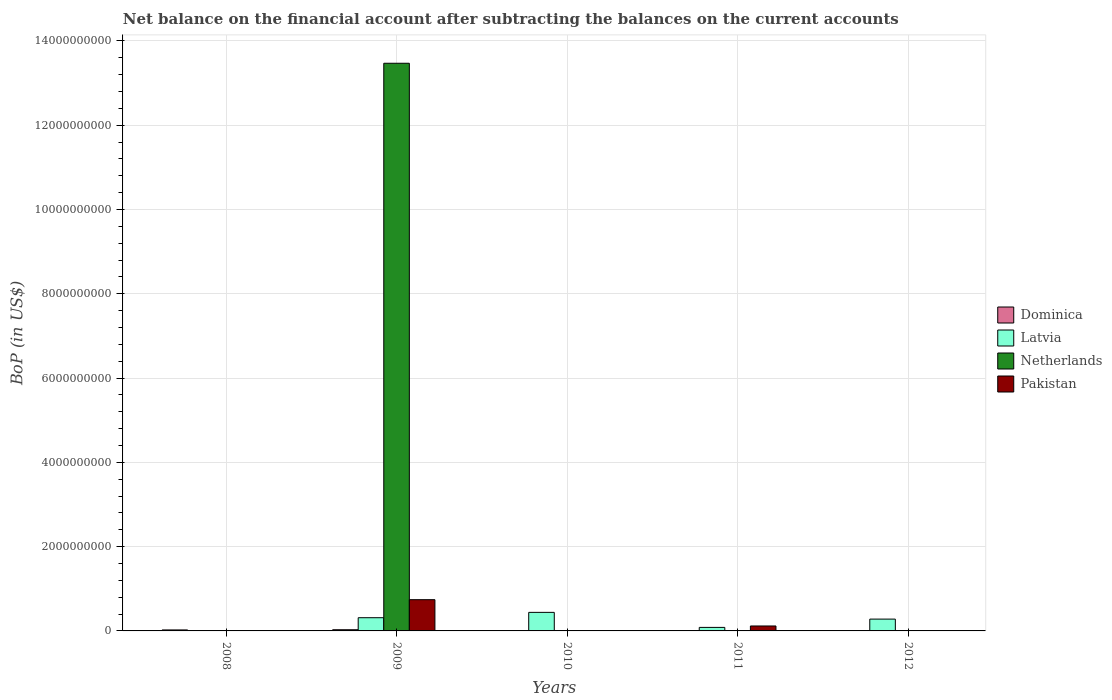Are the number of bars on each tick of the X-axis equal?
Keep it short and to the point. No. How many bars are there on the 4th tick from the left?
Ensure brevity in your answer.  2. What is the Balance of Payments in Latvia in 2010?
Offer a very short reply. 4.40e+08. Across all years, what is the maximum Balance of Payments in Dominica?
Make the answer very short. 2.83e+07. In which year was the Balance of Payments in Pakistan maximum?
Offer a terse response. 2009. What is the total Balance of Payments in Netherlands in the graph?
Your answer should be very brief. 1.35e+1. What is the difference between the Balance of Payments in Latvia in 2010 and that in 2012?
Your answer should be compact. 1.60e+08. What is the difference between the Balance of Payments in Netherlands in 2008 and the Balance of Payments in Latvia in 2009?
Your answer should be very brief. -3.13e+08. What is the average Balance of Payments in Dominica per year?
Offer a terse response. 1.20e+07. In the year 2009, what is the difference between the Balance of Payments in Latvia and Balance of Payments in Pakistan?
Offer a very short reply. -4.28e+08. In how many years, is the Balance of Payments in Netherlands greater than 800000000 US$?
Provide a succinct answer. 1. What is the ratio of the Balance of Payments in Dominica in 2008 to that in 2009?
Your response must be concise. 0.83. What is the difference between the highest and the second highest Balance of Payments in Dominica?
Offer a very short reply. 4.71e+06. What is the difference between the highest and the lowest Balance of Payments in Netherlands?
Ensure brevity in your answer.  1.35e+1. In how many years, is the Balance of Payments in Dominica greater than the average Balance of Payments in Dominica taken over all years?
Your answer should be compact. 2. How many bars are there?
Keep it short and to the point. 10. Are all the bars in the graph horizontal?
Make the answer very short. No. How many legend labels are there?
Make the answer very short. 4. What is the title of the graph?
Make the answer very short. Net balance on the financial account after subtracting the balances on the current accounts. What is the label or title of the Y-axis?
Ensure brevity in your answer.  BoP (in US$). What is the BoP (in US$) in Dominica in 2008?
Offer a terse response. 2.36e+07. What is the BoP (in US$) in Latvia in 2008?
Your answer should be compact. 0. What is the BoP (in US$) of Netherlands in 2008?
Your response must be concise. 0. What is the BoP (in US$) in Pakistan in 2008?
Make the answer very short. 0. What is the BoP (in US$) in Dominica in 2009?
Ensure brevity in your answer.  2.83e+07. What is the BoP (in US$) in Latvia in 2009?
Ensure brevity in your answer.  3.13e+08. What is the BoP (in US$) of Netherlands in 2009?
Your response must be concise. 1.35e+1. What is the BoP (in US$) of Pakistan in 2009?
Provide a succinct answer. 7.41e+08. What is the BoP (in US$) in Dominica in 2010?
Ensure brevity in your answer.  0. What is the BoP (in US$) in Latvia in 2010?
Your answer should be very brief. 4.40e+08. What is the BoP (in US$) in Netherlands in 2010?
Ensure brevity in your answer.  0. What is the BoP (in US$) of Latvia in 2011?
Ensure brevity in your answer.  8.38e+07. What is the BoP (in US$) of Pakistan in 2011?
Make the answer very short. 1.17e+08. What is the BoP (in US$) of Dominica in 2012?
Give a very brief answer. 8.08e+06. What is the BoP (in US$) of Latvia in 2012?
Your answer should be compact. 2.81e+08. What is the BoP (in US$) of Netherlands in 2012?
Offer a terse response. 0. Across all years, what is the maximum BoP (in US$) in Dominica?
Provide a short and direct response. 2.83e+07. Across all years, what is the maximum BoP (in US$) of Latvia?
Offer a very short reply. 4.40e+08. Across all years, what is the maximum BoP (in US$) in Netherlands?
Make the answer very short. 1.35e+1. Across all years, what is the maximum BoP (in US$) in Pakistan?
Make the answer very short. 7.41e+08. Across all years, what is the minimum BoP (in US$) in Dominica?
Make the answer very short. 0. Across all years, what is the minimum BoP (in US$) of Netherlands?
Your answer should be very brief. 0. What is the total BoP (in US$) of Dominica in the graph?
Give a very brief answer. 5.99e+07. What is the total BoP (in US$) of Latvia in the graph?
Offer a terse response. 1.12e+09. What is the total BoP (in US$) of Netherlands in the graph?
Provide a short and direct response. 1.35e+1. What is the total BoP (in US$) in Pakistan in the graph?
Your answer should be compact. 8.59e+08. What is the difference between the BoP (in US$) of Dominica in 2008 and that in 2009?
Ensure brevity in your answer.  -4.71e+06. What is the difference between the BoP (in US$) in Dominica in 2008 and that in 2012?
Offer a very short reply. 1.55e+07. What is the difference between the BoP (in US$) of Latvia in 2009 and that in 2010?
Make the answer very short. -1.27e+08. What is the difference between the BoP (in US$) in Latvia in 2009 and that in 2011?
Provide a short and direct response. 2.30e+08. What is the difference between the BoP (in US$) in Pakistan in 2009 and that in 2011?
Keep it short and to the point. 6.24e+08. What is the difference between the BoP (in US$) of Dominica in 2009 and that in 2012?
Offer a terse response. 2.02e+07. What is the difference between the BoP (in US$) in Latvia in 2009 and that in 2012?
Keep it short and to the point. 3.28e+07. What is the difference between the BoP (in US$) of Latvia in 2010 and that in 2011?
Your response must be concise. 3.57e+08. What is the difference between the BoP (in US$) of Latvia in 2010 and that in 2012?
Give a very brief answer. 1.60e+08. What is the difference between the BoP (in US$) in Latvia in 2011 and that in 2012?
Offer a terse response. -1.97e+08. What is the difference between the BoP (in US$) in Dominica in 2008 and the BoP (in US$) in Latvia in 2009?
Your answer should be very brief. -2.90e+08. What is the difference between the BoP (in US$) in Dominica in 2008 and the BoP (in US$) in Netherlands in 2009?
Offer a terse response. -1.34e+1. What is the difference between the BoP (in US$) of Dominica in 2008 and the BoP (in US$) of Pakistan in 2009?
Your response must be concise. -7.18e+08. What is the difference between the BoP (in US$) of Dominica in 2008 and the BoP (in US$) of Latvia in 2010?
Give a very brief answer. -4.17e+08. What is the difference between the BoP (in US$) of Dominica in 2008 and the BoP (in US$) of Latvia in 2011?
Your response must be concise. -6.02e+07. What is the difference between the BoP (in US$) of Dominica in 2008 and the BoP (in US$) of Pakistan in 2011?
Provide a succinct answer. -9.37e+07. What is the difference between the BoP (in US$) in Dominica in 2008 and the BoP (in US$) in Latvia in 2012?
Keep it short and to the point. -2.57e+08. What is the difference between the BoP (in US$) in Dominica in 2009 and the BoP (in US$) in Latvia in 2010?
Your response must be concise. -4.12e+08. What is the difference between the BoP (in US$) in Dominica in 2009 and the BoP (in US$) in Latvia in 2011?
Ensure brevity in your answer.  -5.55e+07. What is the difference between the BoP (in US$) in Dominica in 2009 and the BoP (in US$) in Pakistan in 2011?
Provide a succinct answer. -8.90e+07. What is the difference between the BoP (in US$) in Latvia in 2009 and the BoP (in US$) in Pakistan in 2011?
Ensure brevity in your answer.  1.96e+08. What is the difference between the BoP (in US$) of Netherlands in 2009 and the BoP (in US$) of Pakistan in 2011?
Your response must be concise. 1.34e+1. What is the difference between the BoP (in US$) of Dominica in 2009 and the BoP (in US$) of Latvia in 2012?
Provide a short and direct response. -2.52e+08. What is the difference between the BoP (in US$) of Latvia in 2010 and the BoP (in US$) of Pakistan in 2011?
Offer a terse response. 3.23e+08. What is the average BoP (in US$) of Dominica per year?
Offer a very short reply. 1.20e+07. What is the average BoP (in US$) of Latvia per year?
Your answer should be compact. 2.24e+08. What is the average BoP (in US$) of Netherlands per year?
Make the answer very short. 2.69e+09. What is the average BoP (in US$) in Pakistan per year?
Your response must be concise. 1.72e+08. In the year 2009, what is the difference between the BoP (in US$) of Dominica and BoP (in US$) of Latvia?
Provide a succinct answer. -2.85e+08. In the year 2009, what is the difference between the BoP (in US$) of Dominica and BoP (in US$) of Netherlands?
Give a very brief answer. -1.34e+1. In the year 2009, what is the difference between the BoP (in US$) in Dominica and BoP (in US$) in Pakistan?
Your answer should be very brief. -7.13e+08. In the year 2009, what is the difference between the BoP (in US$) in Latvia and BoP (in US$) in Netherlands?
Provide a succinct answer. -1.32e+1. In the year 2009, what is the difference between the BoP (in US$) in Latvia and BoP (in US$) in Pakistan?
Provide a short and direct response. -4.28e+08. In the year 2009, what is the difference between the BoP (in US$) in Netherlands and BoP (in US$) in Pakistan?
Your answer should be very brief. 1.27e+1. In the year 2011, what is the difference between the BoP (in US$) in Latvia and BoP (in US$) in Pakistan?
Give a very brief answer. -3.35e+07. In the year 2012, what is the difference between the BoP (in US$) in Dominica and BoP (in US$) in Latvia?
Offer a very short reply. -2.73e+08. What is the ratio of the BoP (in US$) of Dominica in 2008 to that in 2009?
Provide a succinct answer. 0.83. What is the ratio of the BoP (in US$) in Dominica in 2008 to that in 2012?
Your answer should be very brief. 2.92. What is the ratio of the BoP (in US$) in Latvia in 2009 to that in 2010?
Keep it short and to the point. 0.71. What is the ratio of the BoP (in US$) of Latvia in 2009 to that in 2011?
Offer a very short reply. 3.74. What is the ratio of the BoP (in US$) in Pakistan in 2009 to that in 2011?
Offer a terse response. 6.32. What is the ratio of the BoP (in US$) of Dominica in 2009 to that in 2012?
Ensure brevity in your answer.  3.5. What is the ratio of the BoP (in US$) in Latvia in 2009 to that in 2012?
Provide a short and direct response. 1.12. What is the ratio of the BoP (in US$) of Latvia in 2010 to that in 2011?
Provide a succinct answer. 5.26. What is the ratio of the BoP (in US$) of Latvia in 2010 to that in 2012?
Offer a very short reply. 1.57. What is the ratio of the BoP (in US$) in Latvia in 2011 to that in 2012?
Your answer should be very brief. 0.3. What is the difference between the highest and the second highest BoP (in US$) in Dominica?
Provide a succinct answer. 4.71e+06. What is the difference between the highest and the second highest BoP (in US$) of Latvia?
Your answer should be very brief. 1.27e+08. What is the difference between the highest and the lowest BoP (in US$) in Dominica?
Your response must be concise. 2.83e+07. What is the difference between the highest and the lowest BoP (in US$) in Latvia?
Provide a succinct answer. 4.40e+08. What is the difference between the highest and the lowest BoP (in US$) in Netherlands?
Your answer should be compact. 1.35e+1. What is the difference between the highest and the lowest BoP (in US$) of Pakistan?
Offer a terse response. 7.41e+08. 